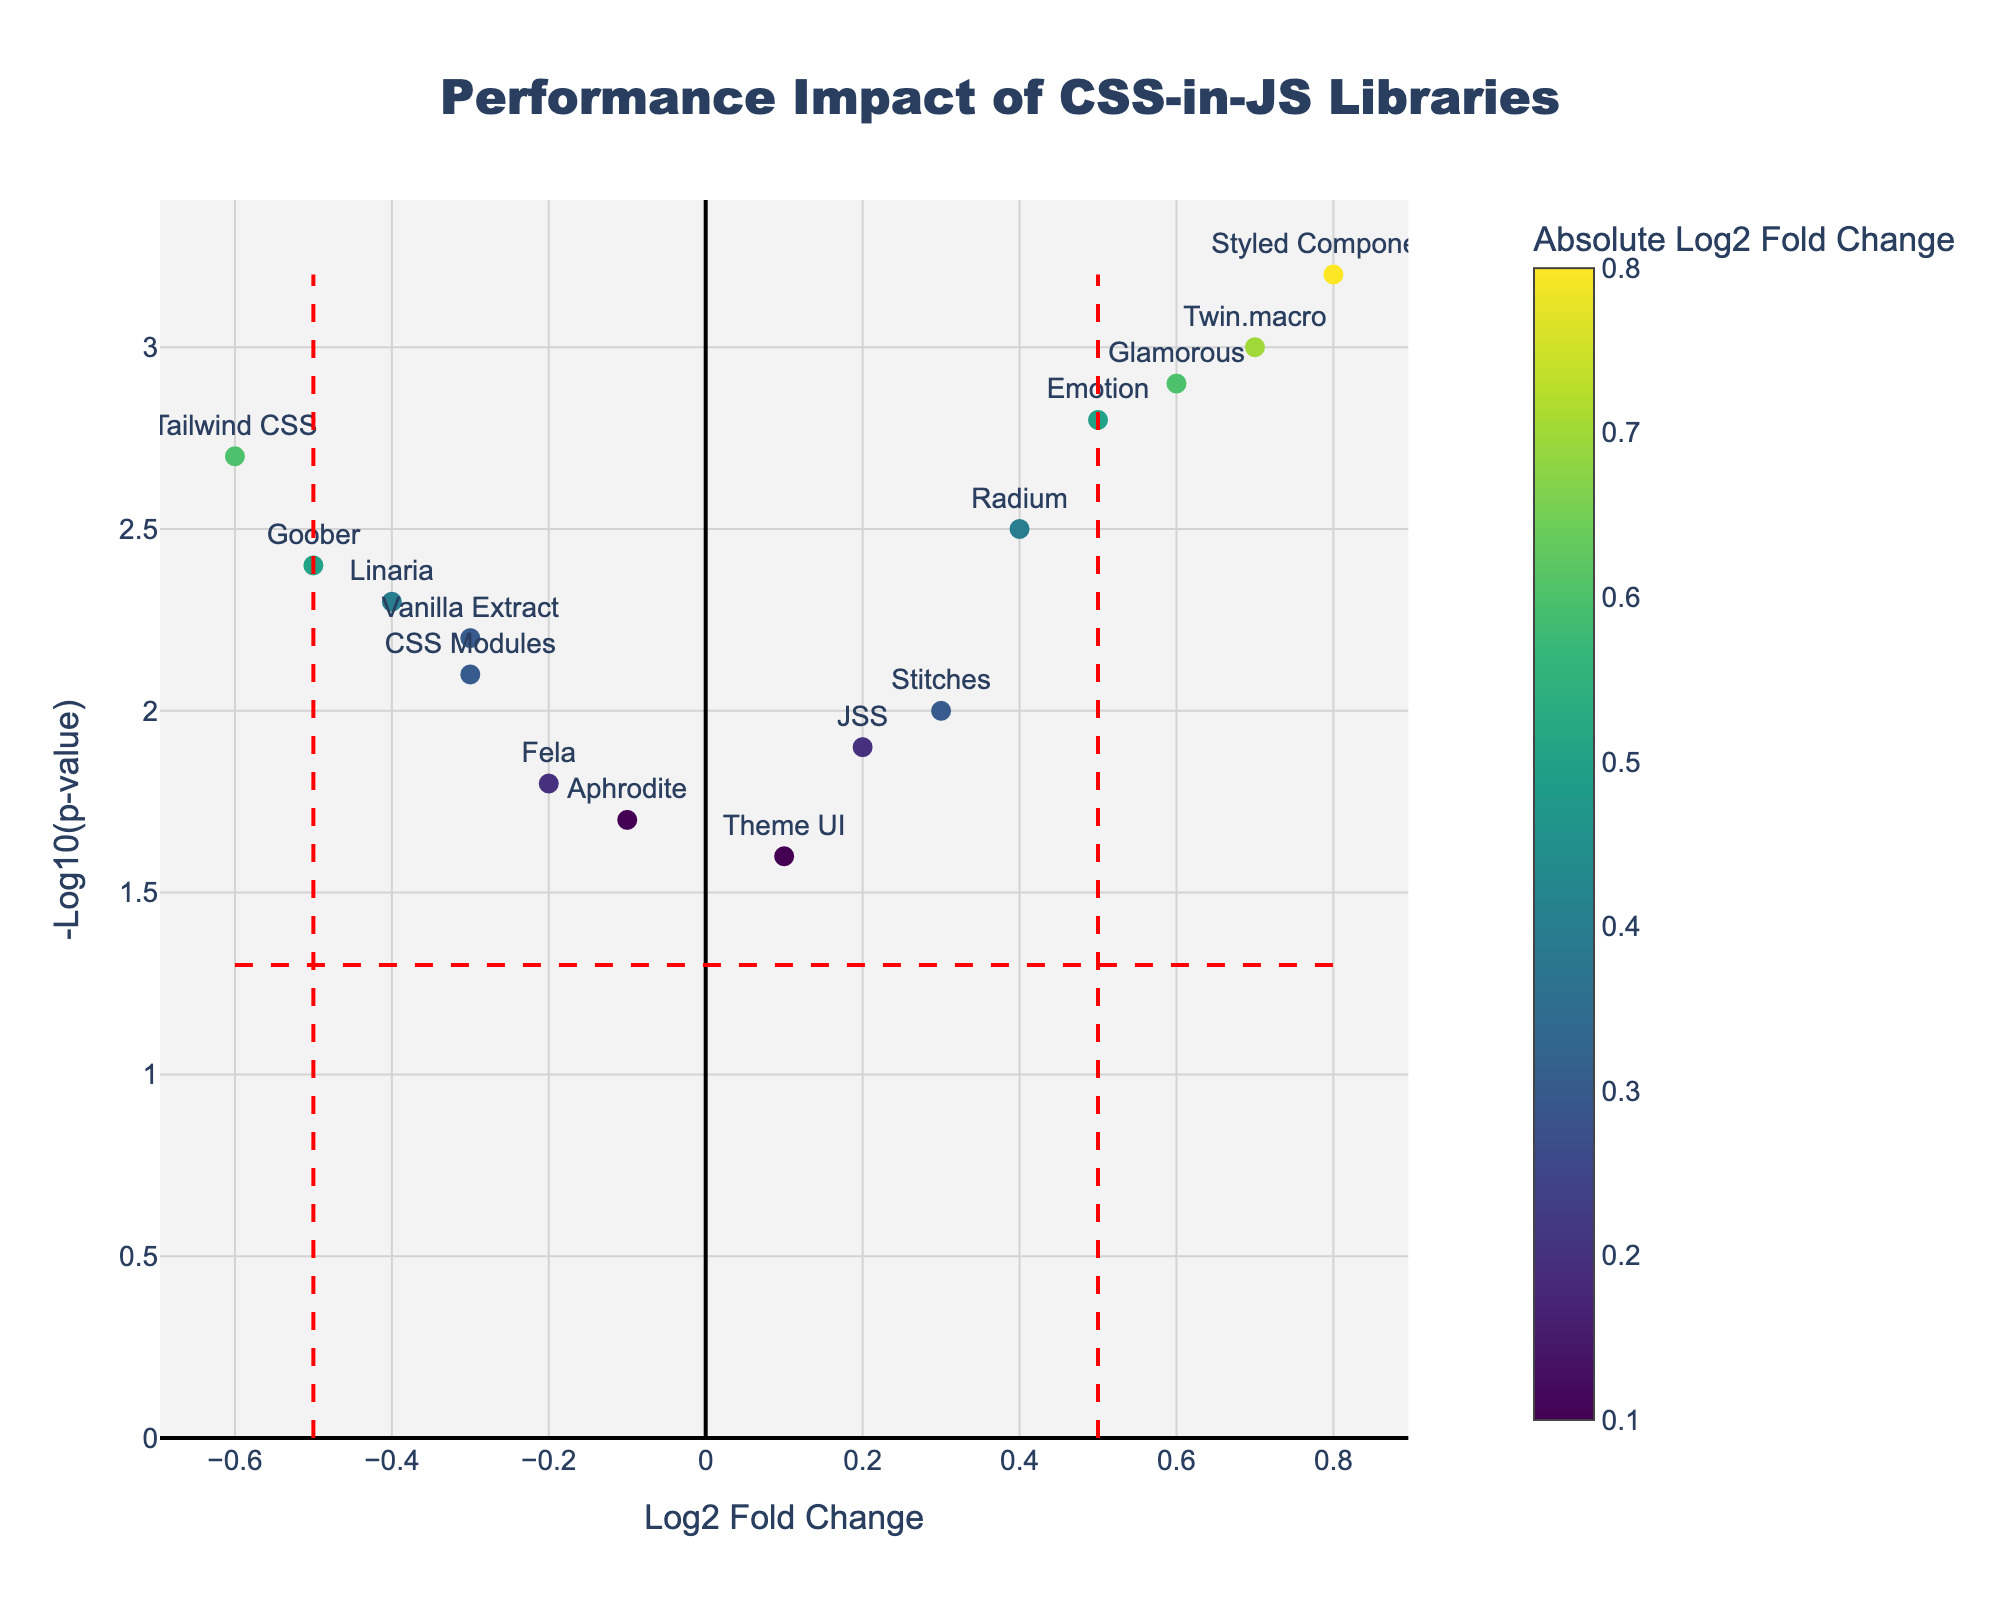What is the title of the plot? The plot title is usually placed at the top of the figure. It provides an overview of what the data represents. In this case, the title "Performance Impact of CSS-in-JS Libraries" is clearly stated at the top center of the plot.
Answer: Performance Impact of CSS-in-JS Libraries How many libraries have a log2 fold change greater than 0? To answer this, count the number of data points to the right of the y-axis (x=0). These points represent libraries with a positive log2 fold change. The libraries are Styled Components, Emotion, JSS, Radium, Glamorous, Twin.macro, and Stitches, making a total of 7.
Answer: 7 Which library has the highest -log10(p-value)? Look for the data point with the highest position on the y-axis. The labeled point "Styled Components" is at the topmost position with a -log10(p-value) of 3.2, indicating it has the highest value.
Answer: Styled Components What is the log2 fold change and -log10(p-value) of Emotion? Locate the “Emotion” label on the plot and read its coordinates on the x and y axes. The plot shows that Emotion is at (0.5, 2.8).
Answer: log2FC: 0.5, -log10(p-value): 2.8 How many libraries have a -log10(p-value) above 2.5? Count the number of data points above the horizontal line at y=2.5. The points meeting this criterion are from Styled Components, Emotion, Glamorous, and Twin.macro, totaling 4.
Answer: 4 Which library shows the least impact with a log2 fold change closest to zero? Check the data points closest to the y-axis (x=0), focusing on the smallest log2 fold change. Theme UI (0.1) and JSS (0.2) have values close to zero. Theme UI is slightly closer to zero.
Answer: Theme UI Which libraries are considered statistically significant but have negative impact (log2 fold change < 0 and -log10(p-value) > p_threshold)? Look for data points to the left of the vertical threshold line at x=-0.5 and above the horizontal significance line at y=1.3. Goober and Linaria meet these criteria.
Answer: Goober, Linaria What is the log2 fold change range of the CSS-in-JS libraries plotted? Check the minimum and maximum values on the x-axis for the data points. The lowest value is for Tailwind CSS at -0.6, and the highest value is for Styled Components at 0.8.
Answer: -0.6 to 0.8 